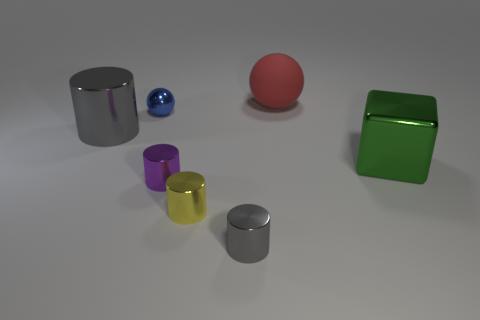Are there any other things that have the same material as the big sphere?
Give a very brief answer. No. There is a sphere left of the tiny gray metallic cylinder that is right of the tiny yellow shiny thing; what is its color?
Give a very brief answer. Blue. What is the material of the cylinder that is the same size as the cube?
Keep it short and to the point. Metal. What number of matte things are purple things or gray cylinders?
Offer a terse response. 0. What color is the large object that is right of the yellow cylinder and on the left side of the green object?
Give a very brief answer. Red. There is a small yellow thing; what number of tiny yellow cylinders are to the right of it?
Offer a very short reply. 0. What is the material of the tiny gray object?
Ensure brevity in your answer.  Metal. There is a object behind the small metal ball that is behind the big metal thing on the right side of the small gray cylinder; what color is it?
Give a very brief answer. Red. What number of yellow objects are the same size as the red ball?
Ensure brevity in your answer.  0. There is a tiny object that is behind the large metal cylinder; what color is it?
Offer a terse response. Blue. 